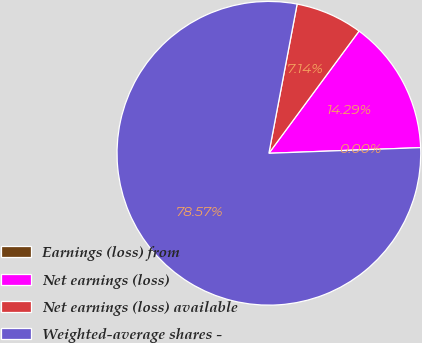Convert chart. <chart><loc_0><loc_0><loc_500><loc_500><pie_chart><fcel>Earnings (loss) from<fcel>Net earnings (loss)<fcel>Net earnings (loss) available<fcel>Weighted-average shares -<nl><fcel>0.0%<fcel>14.29%<fcel>7.14%<fcel>78.57%<nl></chart> 